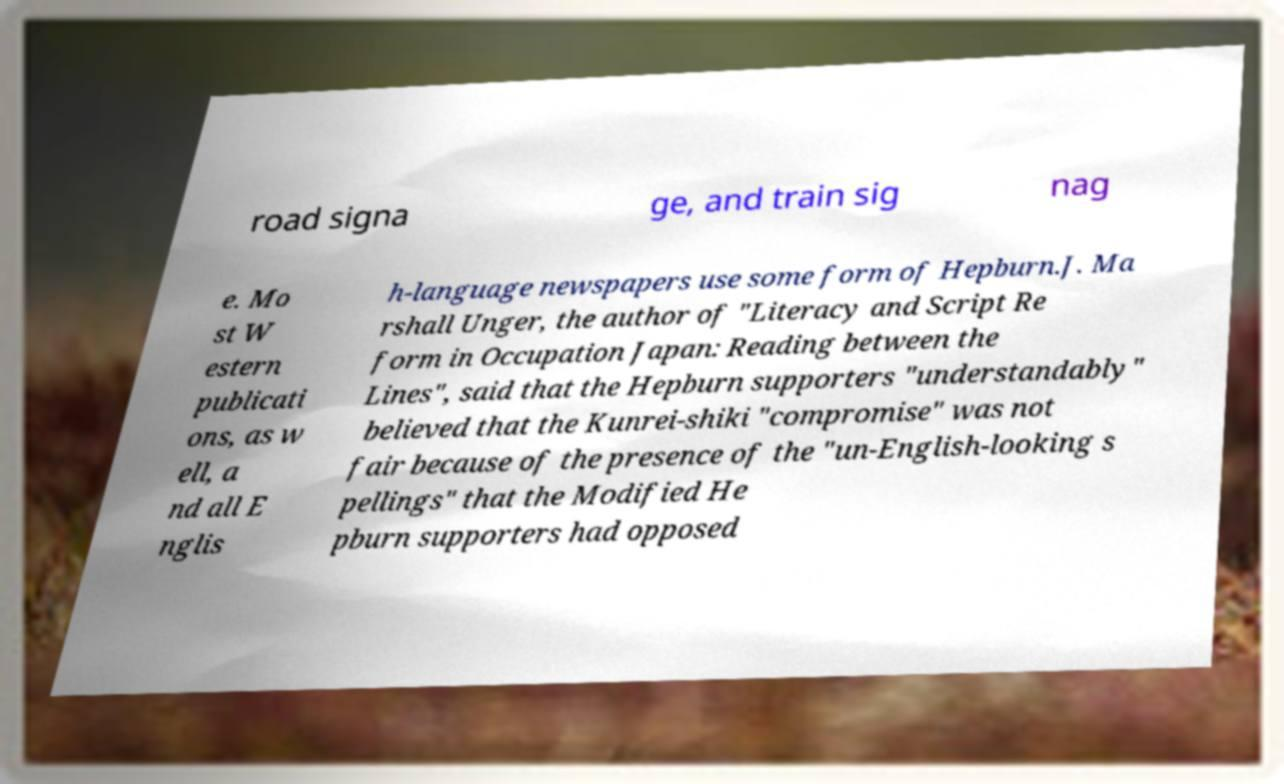Can you read and provide the text displayed in the image?This photo seems to have some interesting text. Can you extract and type it out for me? road signa ge, and train sig nag e. Mo st W estern publicati ons, as w ell, a nd all E nglis h-language newspapers use some form of Hepburn.J. Ma rshall Unger, the author of "Literacy and Script Re form in Occupation Japan: Reading between the Lines", said that the Hepburn supporters "understandably" believed that the Kunrei-shiki "compromise" was not fair because of the presence of the "un-English-looking s pellings" that the Modified He pburn supporters had opposed 